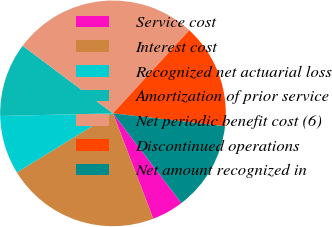Convert chart to OTSL. <chart><loc_0><loc_0><loc_500><loc_500><pie_chart><fcel>Service cost<fcel>Interest cost<fcel>Recognized net actuarial loss<fcel>Amortization of prior service<fcel>Net periodic benefit cost (6)<fcel>Discontinued operations<fcel>Net amount recognized in<nl><fcel>4.55%<fcel>22.04%<fcel>8.4%<fcel>10.6%<fcel>26.59%<fcel>15.01%<fcel>12.81%<nl></chart> 